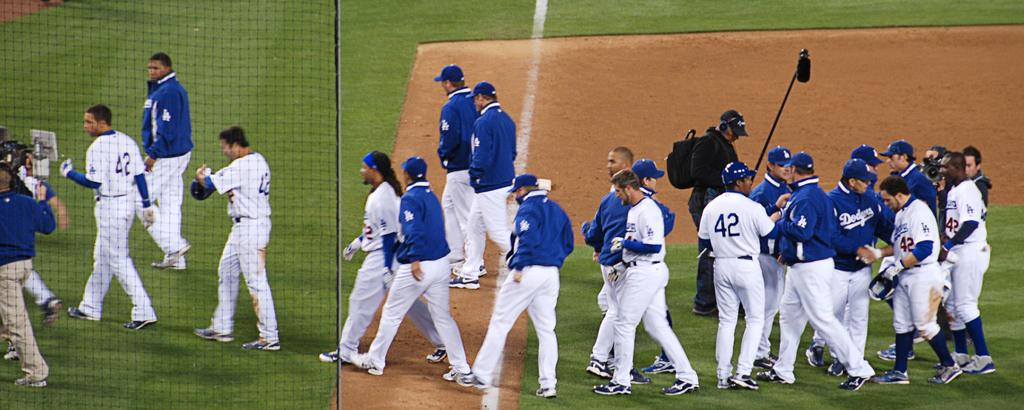<image>
Write a terse but informative summary of the picture. The Dodgers team is congratulating each other after a game. 